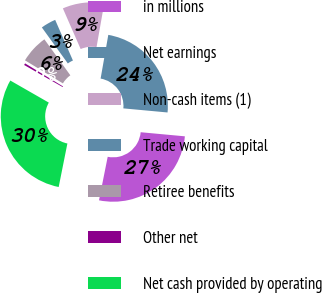Convert chart. <chart><loc_0><loc_0><loc_500><loc_500><pie_chart><fcel>in millions<fcel>Net earnings<fcel>Non-cash items (1)<fcel>Trade working capital<fcel>Retiree benefits<fcel>Other net<fcel>Net cash provided by operating<nl><fcel>26.67%<fcel>23.7%<fcel>9.33%<fcel>3.39%<fcel>6.36%<fcel>0.41%<fcel>30.14%<nl></chart> 